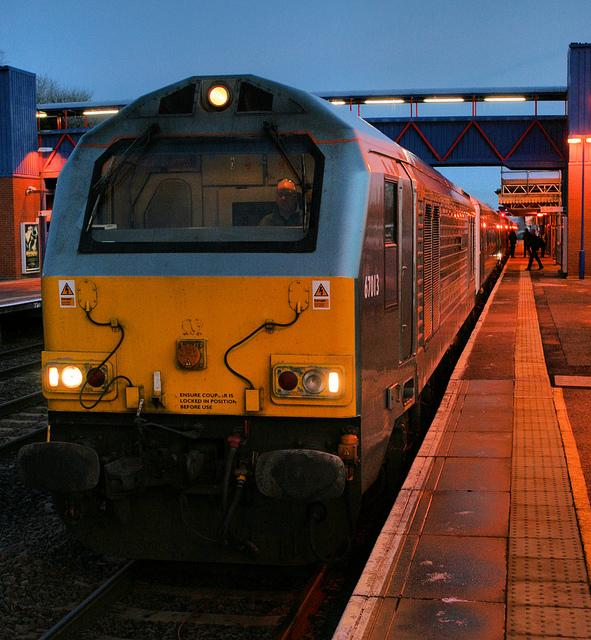What is the man inside the front of the training doing? driving 